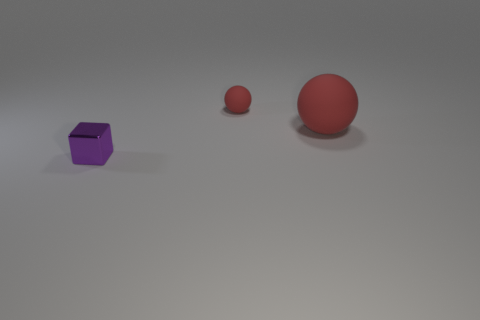There is a red ball that is the same size as the purple object; what material is it?
Keep it short and to the point. Rubber. Is the tiny red sphere made of the same material as the block?
Provide a succinct answer. No. How many objects are rubber spheres or small red rubber balls?
Offer a very short reply. 2. What shape is the thing that is in front of the big object?
Ensure brevity in your answer.  Cube. The other sphere that is made of the same material as the tiny red sphere is what color?
Offer a very short reply. Red. The tiny red matte thing has what shape?
Your response must be concise. Sphere. What material is the thing that is in front of the small red rubber thing and on the left side of the large red matte sphere?
Your response must be concise. Metal. There is another red object that is made of the same material as the large thing; what is its size?
Keep it short and to the point. Small. There is a thing that is both on the left side of the big red ball and behind the purple metal object; what is its shape?
Provide a short and direct response. Sphere. What is the size of the object that is to the left of the tiny thing that is right of the purple shiny thing?
Provide a succinct answer. Small. 